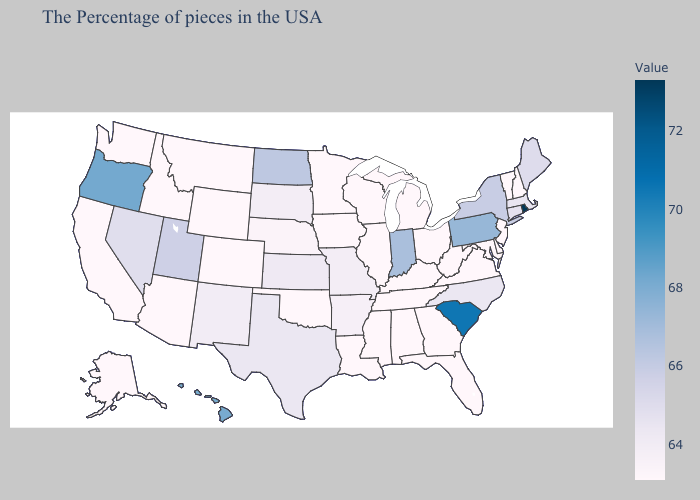Which states hav the highest value in the South?
Quick response, please. South Carolina. Which states hav the highest value in the West?
Concise answer only. Oregon. Among the states that border Rhode Island , does Connecticut have the highest value?
Quick response, please. Yes. Among the states that border Idaho , which have the highest value?
Answer briefly. Oregon. 